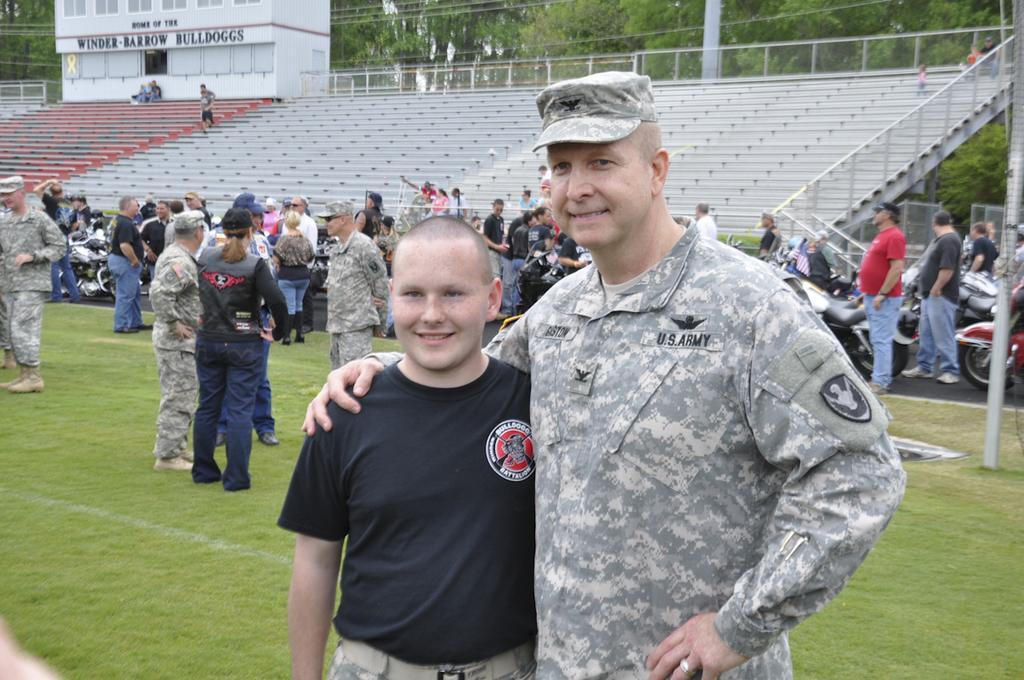In one or two sentences, can you explain what this image depicts? In this image we can see many people. Some are wearing caps. On the ground there is grass. In the back there are vehicles. Also there are steps and railings. And there is a building with name. In the background there are trees. 